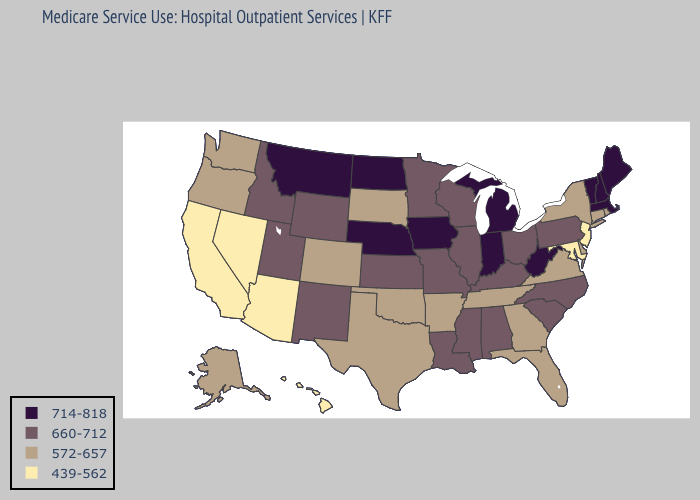Does South Carolina have the highest value in the South?
Give a very brief answer. No. Which states hav the highest value in the Northeast?
Write a very short answer. Maine, Massachusetts, New Hampshire, Vermont. Name the states that have a value in the range 439-562?
Give a very brief answer. Arizona, California, Hawaii, Maryland, Nevada, New Jersey. Does Alaska have a higher value than Nevada?
Give a very brief answer. Yes. What is the value of Vermont?
Quick response, please. 714-818. What is the value of Ohio?
Be succinct. 660-712. Which states have the highest value in the USA?
Concise answer only. Indiana, Iowa, Maine, Massachusetts, Michigan, Montana, Nebraska, New Hampshire, North Dakota, Vermont, West Virginia. Does Michigan have the highest value in the USA?
Give a very brief answer. Yes. Name the states that have a value in the range 660-712?
Write a very short answer. Alabama, Idaho, Illinois, Kansas, Kentucky, Louisiana, Minnesota, Mississippi, Missouri, New Mexico, North Carolina, Ohio, Pennsylvania, South Carolina, Utah, Wisconsin, Wyoming. What is the lowest value in the Northeast?
Write a very short answer. 439-562. Does Maine have the highest value in the USA?
Answer briefly. Yes. Does North Dakota have the same value as Idaho?
Write a very short answer. No. Name the states that have a value in the range 714-818?
Concise answer only. Indiana, Iowa, Maine, Massachusetts, Michigan, Montana, Nebraska, New Hampshire, North Dakota, Vermont, West Virginia. How many symbols are there in the legend?
Short answer required. 4. 